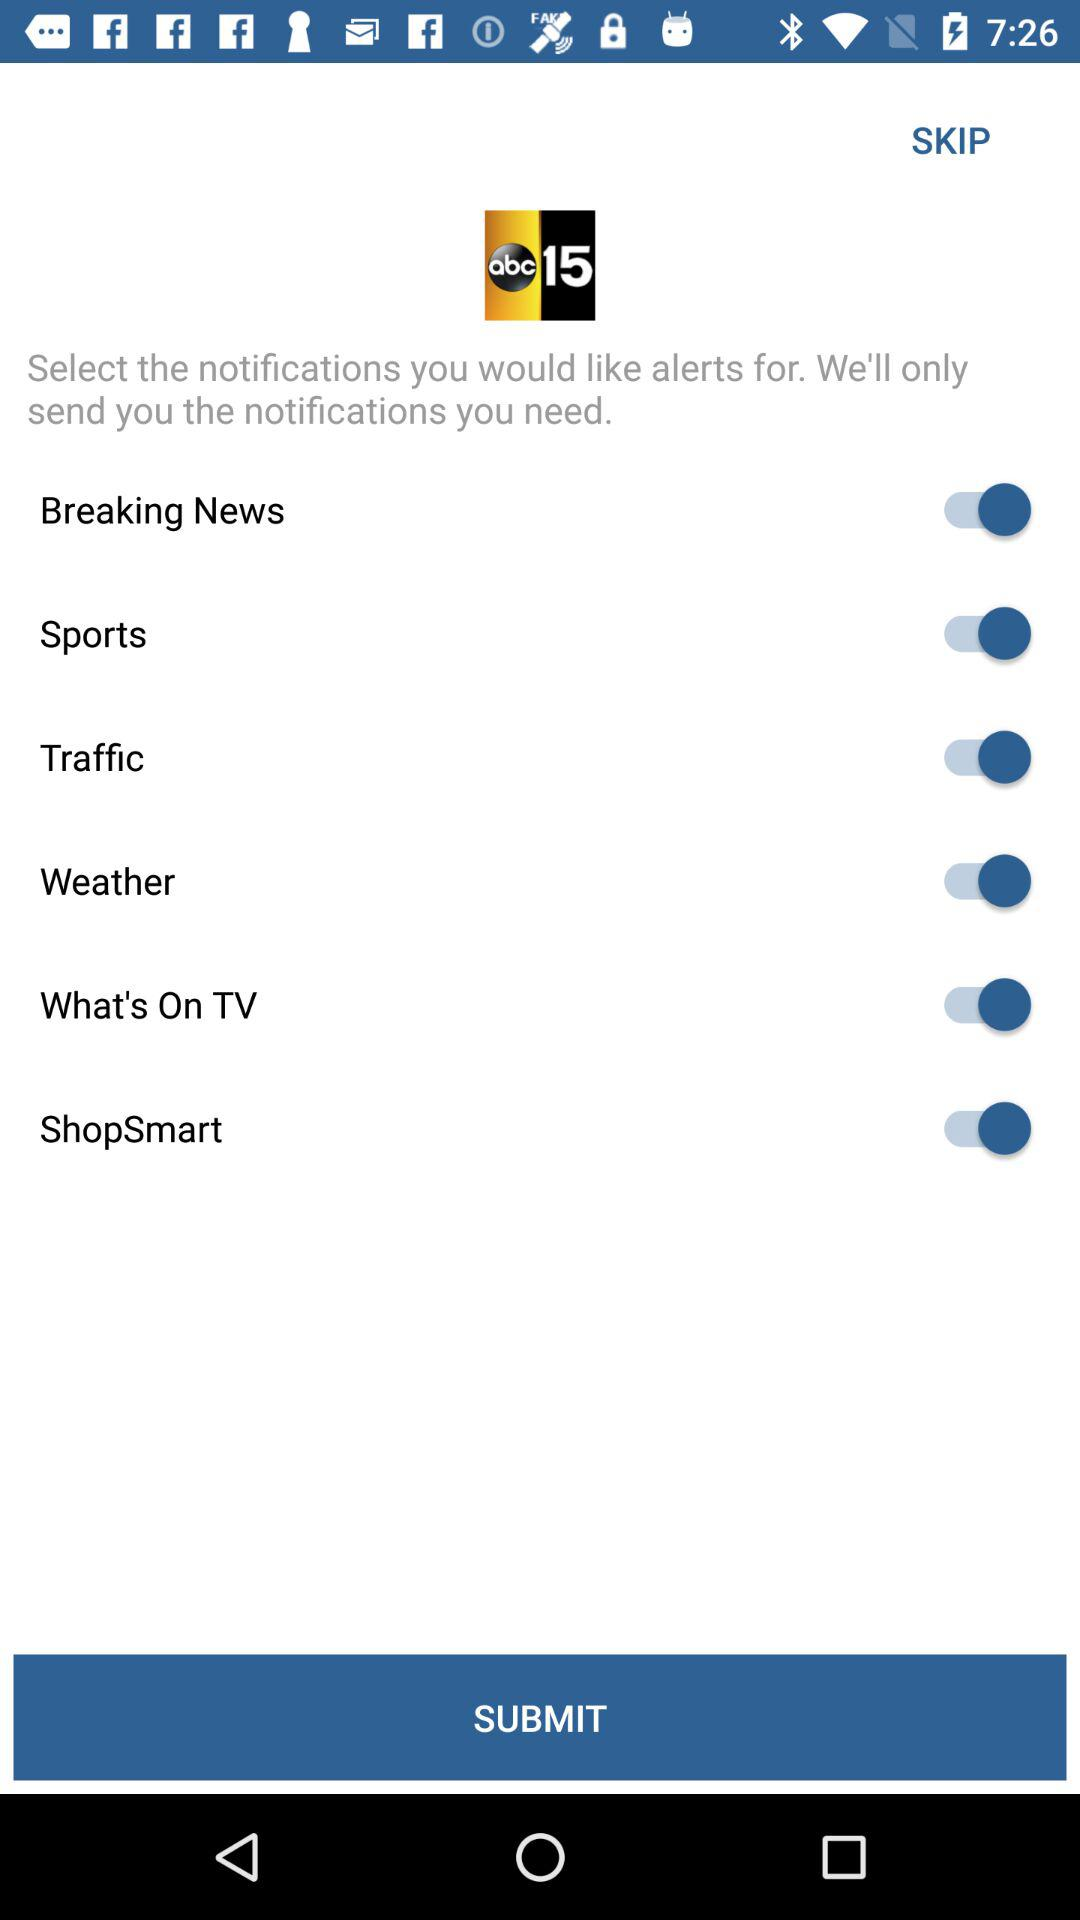What is the status of the "Breaking News" setting? The status is "on". 